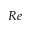<formula> <loc_0><loc_0><loc_500><loc_500>R e</formula> 